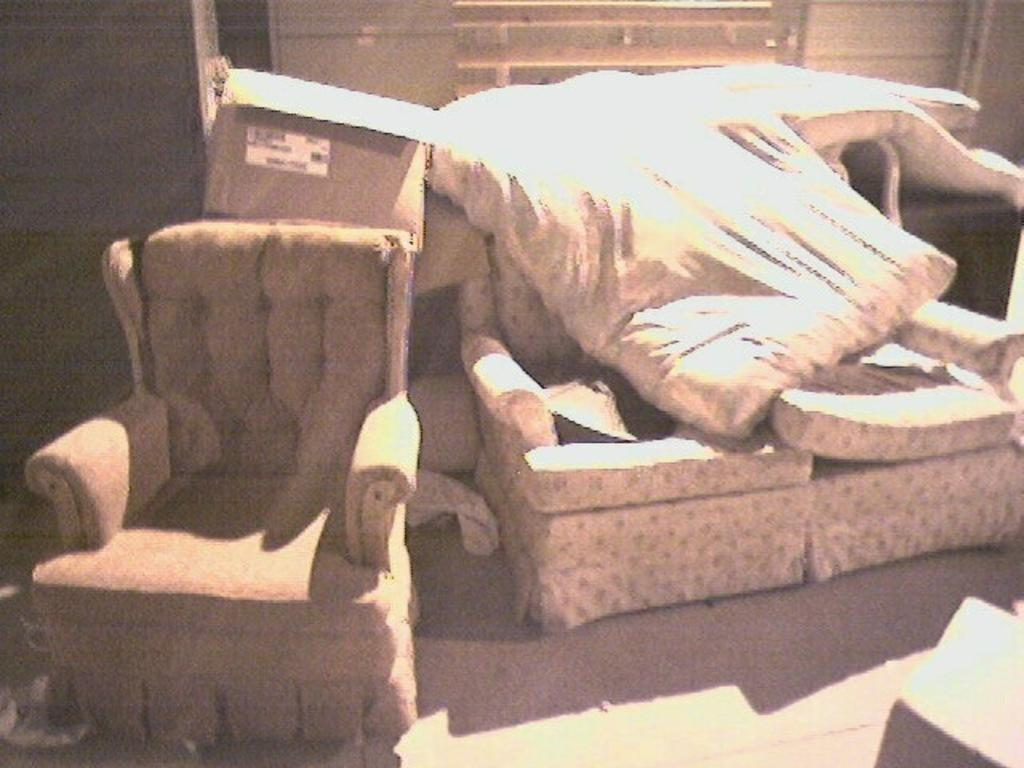What type of furniture is placed on the floor in the image? There is a sofa set on the floor. What is placed on the sofa set? There is a bed and a box on the sofa set. What is visible in the background of the image? There is a wall in the image. What type of knowledge can be gained from the health of the box in the image? There is no indication of the health of the box in the image, and therefore no knowledge can be gained from it. 